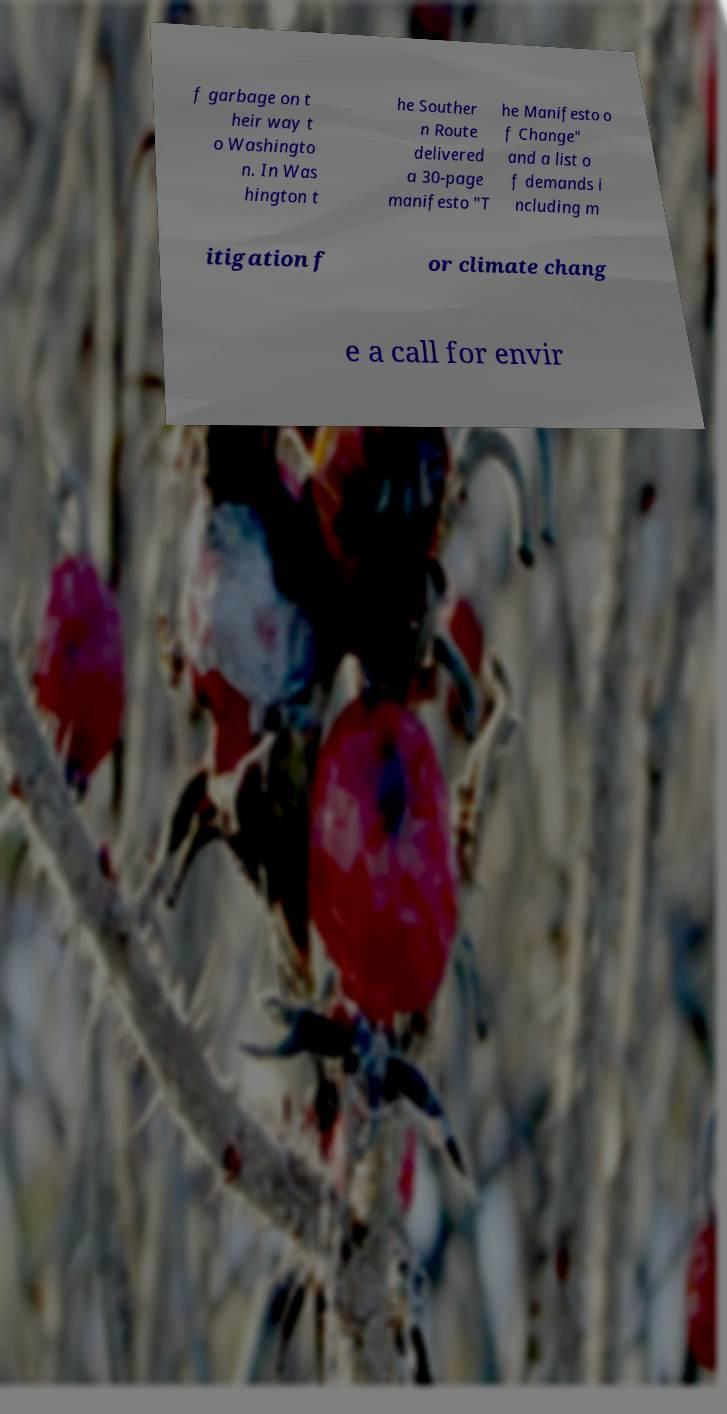Could you extract and type out the text from this image? f garbage on t heir way t o Washingto n. In Was hington t he Souther n Route delivered a 30-page manifesto "T he Manifesto o f Change" and a list o f demands i ncluding m itigation f or climate chang e a call for envir 